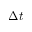Convert formula to latex. <formula><loc_0><loc_0><loc_500><loc_500>\Delta t</formula> 